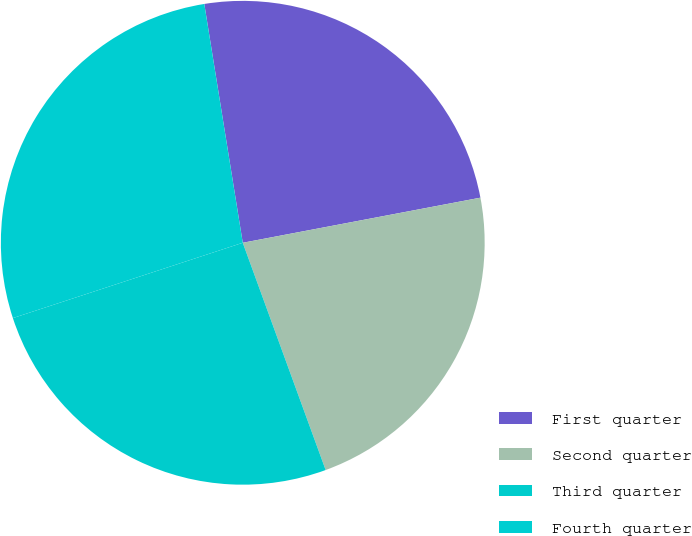<chart> <loc_0><loc_0><loc_500><loc_500><pie_chart><fcel>First quarter<fcel>Second quarter<fcel>Third quarter<fcel>Fourth quarter<nl><fcel>24.56%<fcel>22.42%<fcel>25.53%<fcel>27.5%<nl></chart> 